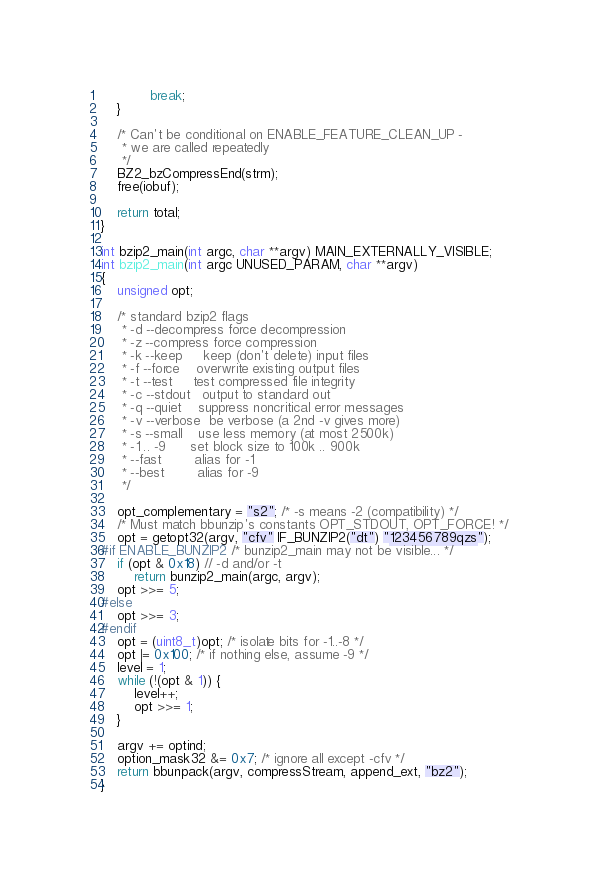<code> <loc_0><loc_0><loc_500><loc_500><_C_>			break;
	}

	/* Can't be conditional on ENABLE_FEATURE_CLEAN_UP -
	 * we are called repeatedly
	 */
	BZ2_bzCompressEnd(strm);
	free(iobuf);

	return total;
}

int bzip2_main(int argc, char **argv) MAIN_EXTERNALLY_VISIBLE;
int bzip2_main(int argc UNUSED_PARAM, char **argv)
{
	unsigned opt;

	/* standard bzip2 flags
	 * -d --decompress force decompression
	 * -z --compress force compression
	 * -k --keep     keep (don't delete) input files
	 * -f --force    overwrite existing output files
	 * -t --test     test compressed file integrity
	 * -c --stdout   output to standard out
	 * -q --quiet    suppress noncritical error messages
	 * -v --verbose  be verbose (a 2nd -v gives more)
	 * -s --small    use less memory (at most 2500k)
	 * -1 .. -9      set block size to 100k .. 900k
	 * --fast        alias for -1
	 * --best        alias for -9
	 */

	opt_complementary = "s2"; /* -s means -2 (compatibility) */
	/* Must match bbunzip's constants OPT_STDOUT, OPT_FORCE! */
	opt = getopt32(argv, "cfv" IF_BUNZIP2("dt") "123456789qzs");
#if ENABLE_BUNZIP2 /* bunzip2_main may not be visible... */
	if (opt & 0x18) // -d and/or -t
		return bunzip2_main(argc, argv);
	opt >>= 5;
#else
	opt >>= 3;
#endif
	opt = (uint8_t)opt; /* isolate bits for -1..-8 */
	opt |= 0x100; /* if nothing else, assume -9 */
	level = 1;
	while (!(opt & 1)) {
		level++;
		opt >>= 1;
	}

	argv += optind;
	option_mask32 &= 0x7; /* ignore all except -cfv */
	return bbunpack(argv, compressStream, append_ext, "bz2");
}
</code> 